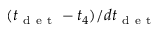Convert formula to latex. <formula><loc_0><loc_0><loc_500><loc_500>( t _ { d e t } - t _ { 4 } ) / d t _ { d e t }</formula> 